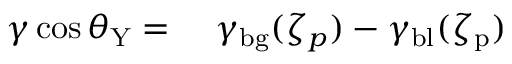<formula> <loc_0><loc_0><loc_500><loc_500>\begin{array} { r l } { \gamma \cos \theta _ { Y } = } & \ \gamma _ { b g } ( \zeta _ { p } ) - \gamma _ { b l } ( \zeta _ { p } ) } \end{array}</formula> 